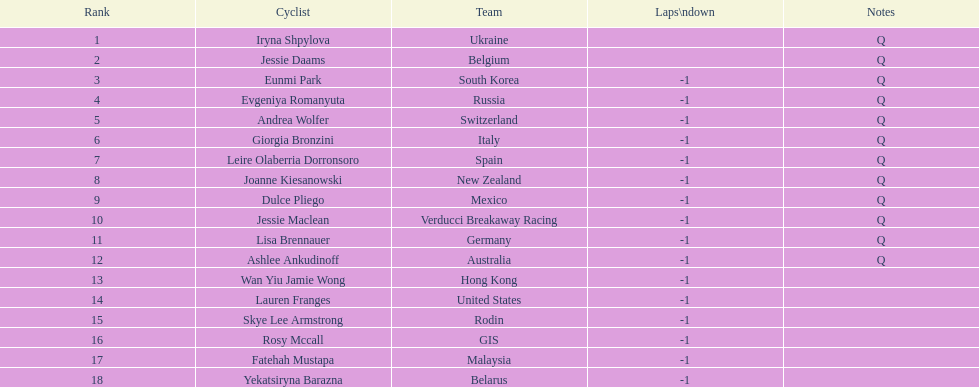How many consecutive notes are there? 12. 